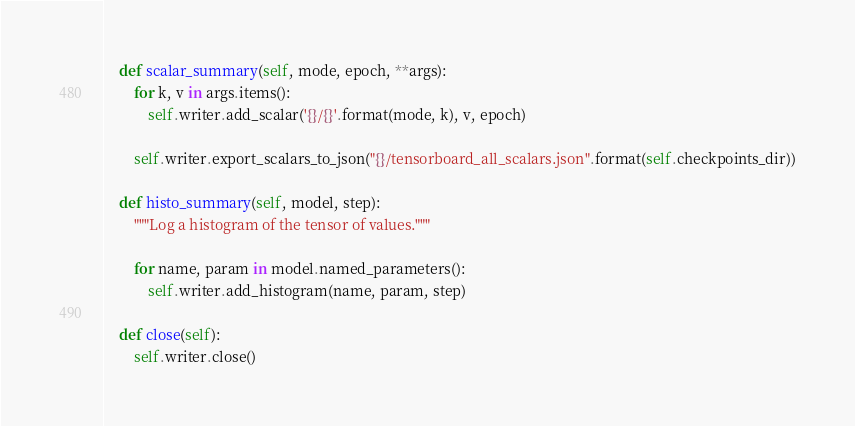Convert code to text. <code><loc_0><loc_0><loc_500><loc_500><_Python_>    def scalar_summary(self, mode, epoch, **args):
        for k, v in args.items():
            self.writer.add_scalar('{}/{}'.format(mode, k), v, epoch)

        self.writer.export_scalars_to_json("{}/tensorboard_all_scalars.json".format(self.checkpoints_dir))

    def histo_summary(self, model, step):
        """Log a histogram of the tensor of values."""

        for name, param in model.named_parameters():
            self.writer.add_histogram(name, param, step)

    def close(self):
        self.writer.close()
</code> 